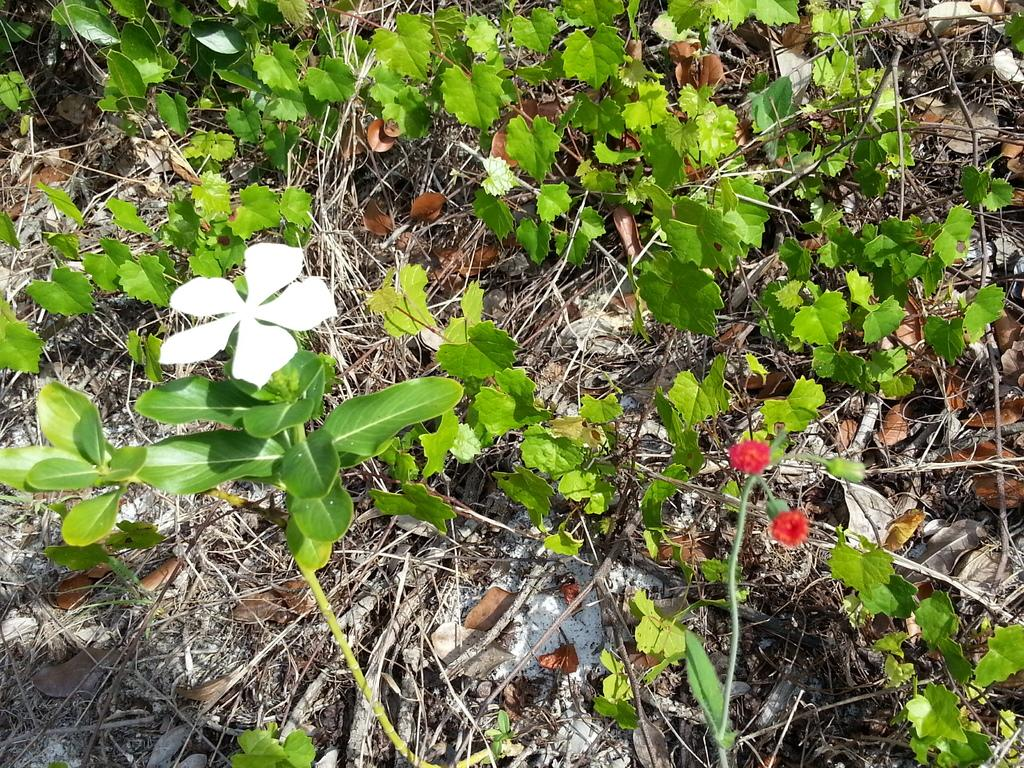What colors are the flowers in the image? The flowers in the image are white and red. Do the flowers have any additional features besides their petals? Yes, the flowers have leaves. What type of vegetation is present in the image besides the flowers? Dry grass is present in the image. What type of seat can be seen in the image? There is no seat present in the image; it features flowers and dry grass. What musical instrument is being played in the image? There is no musical instrument or any indication of music in the image. 